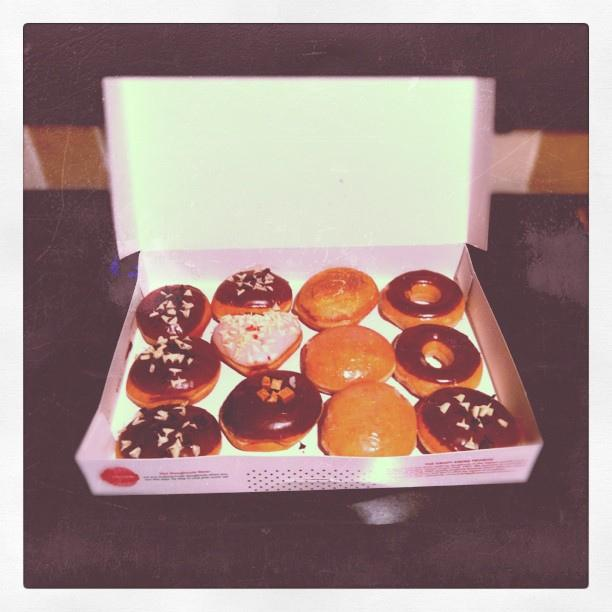What is the box made of? paper 